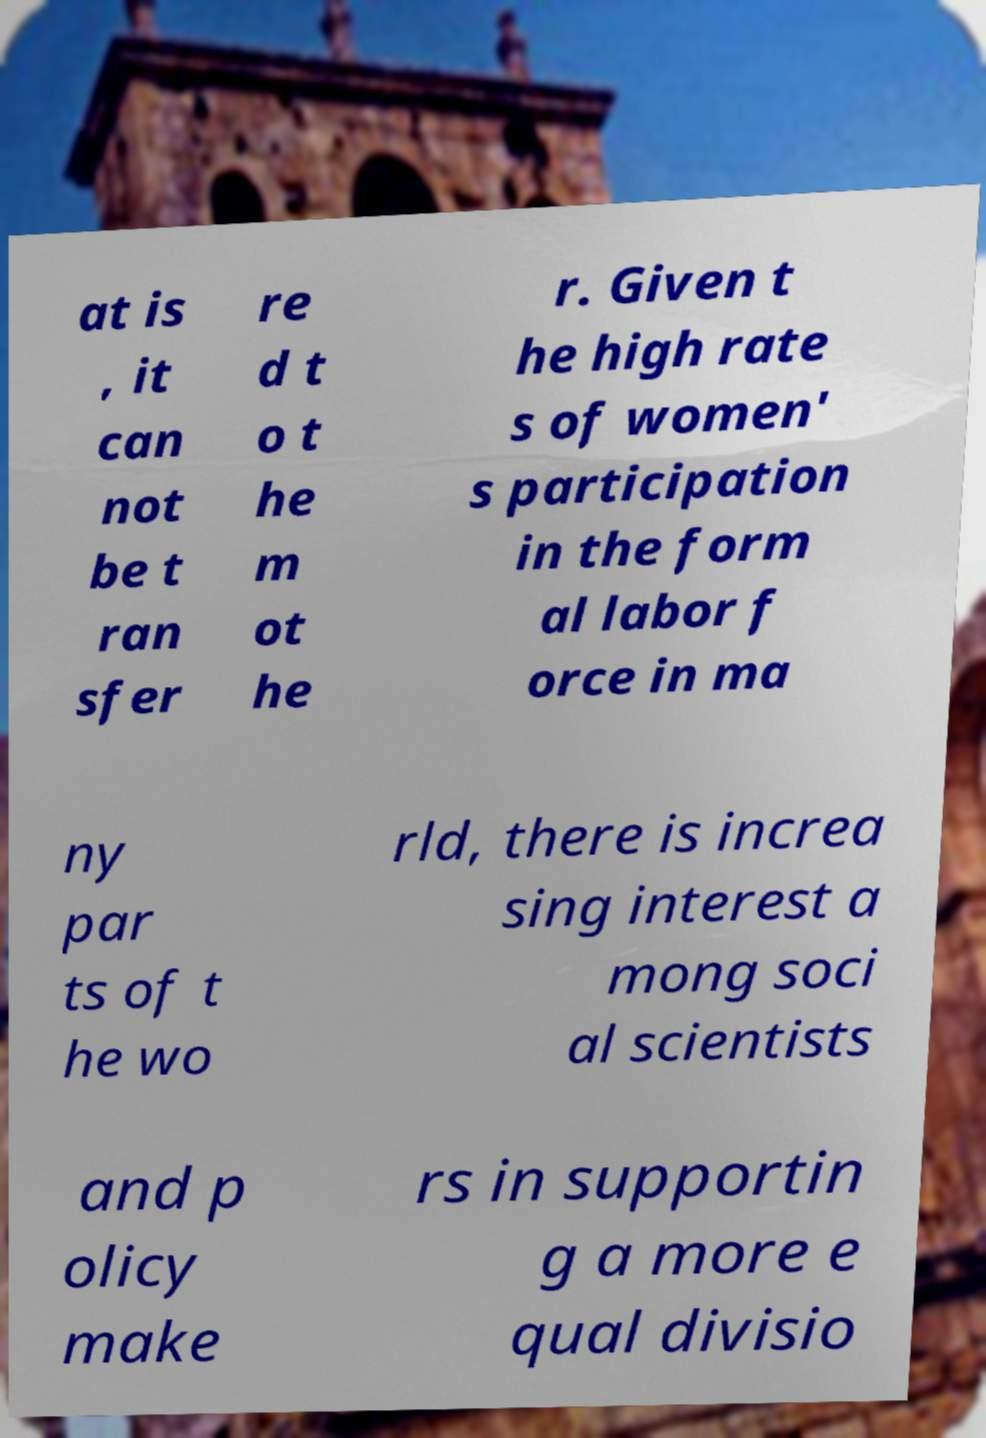What messages or text are displayed in this image? I need them in a readable, typed format. at is , it can not be t ran sfer re d t o t he m ot he r. Given t he high rate s of women' s participation in the form al labor f orce in ma ny par ts of t he wo rld, there is increa sing interest a mong soci al scientists and p olicy make rs in supportin g a more e qual divisio 